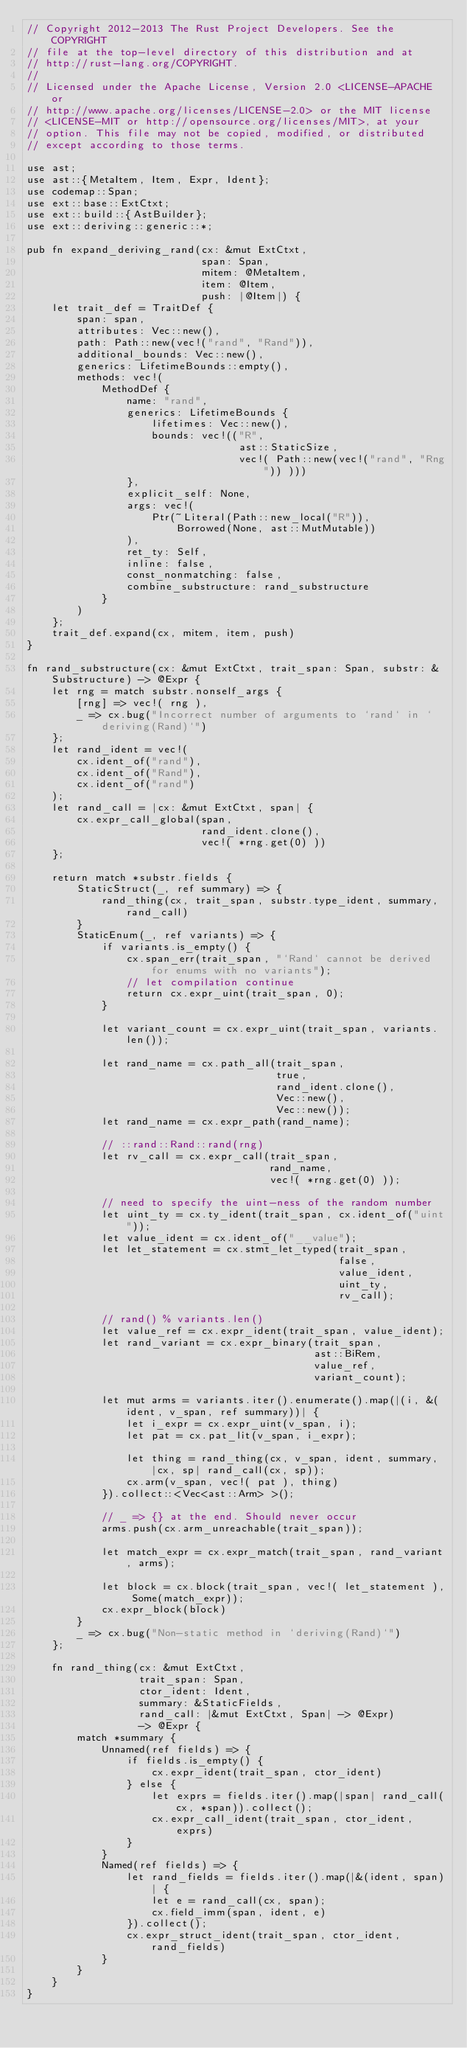<code> <loc_0><loc_0><loc_500><loc_500><_Rust_>// Copyright 2012-2013 The Rust Project Developers. See the COPYRIGHT
// file at the top-level directory of this distribution and at
// http://rust-lang.org/COPYRIGHT.
//
// Licensed under the Apache License, Version 2.0 <LICENSE-APACHE or
// http://www.apache.org/licenses/LICENSE-2.0> or the MIT license
// <LICENSE-MIT or http://opensource.org/licenses/MIT>, at your
// option. This file may not be copied, modified, or distributed
// except according to those terms.

use ast;
use ast::{MetaItem, Item, Expr, Ident};
use codemap::Span;
use ext::base::ExtCtxt;
use ext::build::{AstBuilder};
use ext::deriving::generic::*;

pub fn expand_deriving_rand(cx: &mut ExtCtxt,
                            span: Span,
                            mitem: @MetaItem,
                            item: @Item,
                            push: |@Item|) {
    let trait_def = TraitDef {
        span: span,
        attributes: Vec::new(),
        path: Path::new(vec!("rand", "Rand")),
        additional_bounds: Vec::new(),
        generics: LifetimeBounds::empty(),
        methods: vec!(
            MethodDef {
                name: "rand",
                generics: LifetimeBounds {
                    lifetimes: Vec::new(),
                    bounds: vec!(("R",
                                  ast::StaticSize,
                                  vec!( Path::new(vec!("rand", "Rng")) )))
                },
                explicit_self: None,
                args: vec!(
                    Ptr(~Literal(Path::new_local("R")),
                        Borrowed(None, ast::MutMutable))
                ),
                ret_ty: Self,
                inline: false,
                const_nonmatching: false,
                combine_substructure: rand_substructure
            }
        )
    };
    trait_def.expand(cx, mitem, item, push)
}

fn rand_substructure(cx: &mut ExtCtxt, trait_span: Span, substr: &Substructure) -> @Expr {
    let rng = match substr.nonself_args {
        [rng] => vec!( rng ),
        _ => cx.bug("Incorrect number of arguments to `rand` in `deriving(Rand)`")
    };
    let rand_ident = vec!(
        cx.ident_of("rand"),
        cx.ident_of("Rand"),
        cx.ident_of("rand")
    );
    let rand_call = |cx: &mut ExtCtxt, span| {
        cx.expr_call_global(span,
                            rand_ident.clone(),
                            vec!( *rng.get(0) ))
    };

    return match *substr.fields {
        StaticStruct(_, ref summary) => {
            rand_thing(cx, trait_span, substr.type_ident, summary, rand_call)
        }
        StaticEnum(_, ref variants) => {
            if variants.is_empty() {
                cx.span_err(trait_span, "`Rand` cannot be derived for enums with no variants");
                // let compilation continue
                return cx.expr_uint(trait_span, 0);
            }

            let variant_count = cx.expr_uint(trait_span, variants.len());

            let rand_name = cx.path_all(trait_span,
                                        true,
                                        rand_ident.clone(),
                                        Vec::new(),
                                        Vec::new());
            let rand_name = cx.expr_path(rand_name);

            // ::rand::Rand::rand(rng)
            let rv_call = cx.expr_call(trait_span,
                                       rand_name,
                                       vec!( *rng.get(0) ));

            // need to specify the uint-ness of the random number
            let uint_ty = cx.ty_ident(trait_span, cx.ident_of("uint"));
            let value_ident = cx.ident_of("__value");
            let let_statement = cx.stmt_let_typed(trait_span,
                                                  false,
                                                  value_ident,
                                                  uint_ty,
                                                  rv_call);

            // rand() % variants.len()
            let value_ref = cx.expr_ident(trait_span, value_ident);
            let rand_variant = cx.expr_binary(trait_span,
                                              ast::BiRem,
                                              value_ref,
                                              variant_count);

            let mut arms = variants.iter().enumerate().map(|(i, &(ident, v_span, ref summary))| {
                let i_expr = cx.expr_uint(v_span, i);
                let pat = cx.pat_lit(v_span, i_expr);

                let thing = rand_thing(cx, v_span, ident, summary, |cx, sp| rand_call(cx, sp));
                cx.arm(v_span, vec!( pat ), thing)
            }).collect::<Vec<ast::Arm> >();

            // _ => {} at the end. Should never occur
            arms.push(cx.arm_unreachable(trait_span));

            let match_expr = cx.expr_match(trait_span, rand_variant, arms);

            let block = cx.block(trait_span, vec!( let_statement ), Some(match_expr));
            cx.expr_block(block)
        }
        _ => cx.bug("Non-static method in `deriving(Rand)`")
    };

    fn rand_thing(cx: &mut ExtCtxt,
                  trait_span: Span,
                  ctor_ident: Ident,
                  summary: &StaticFields,
                  rand_call: |&mut ExtCtxt, Span| -> @Expr)
                  -> @Expr {
        match *summary {
            Unnamed(ref fields) => {
                if fields.is_empty() {
                    cx.expr_ident(trait_span, ctor_ident)
                } else {
                    let exprs = fields.iter().map(|span| rand_call(cx, *span)).collect();
                    cx.expr_call_ident(trait_span, ctor_ident, exprs)
                }
            }
            Named(ref fields) => {
                let rand_fields = fields.iter().map(|&(ident, span)| {
                    let e = rand_call(cx, span);
                    cx.field_imm(span, ident, e)
                }).collect();
                cx.expr_struct_ident(trait_span, ctor_ident, rand_fields)
            }
        }
    }
}
</code> 